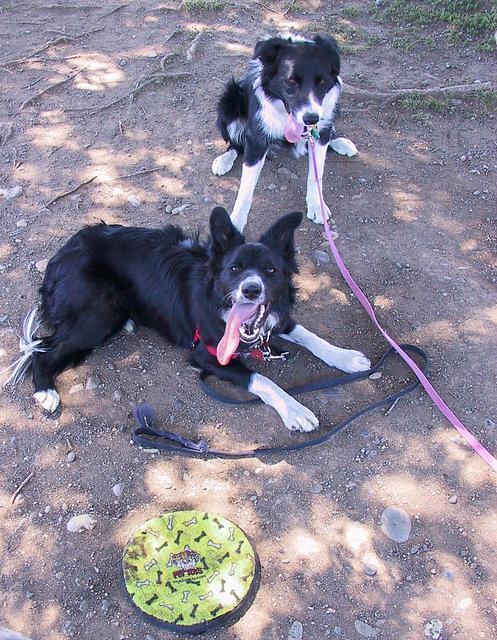What color is the lead to the dog standing to the rear side of the black dog?
Choose the correct response and explain in the format: 'Answer: answer
Rationale: rationale.'
Options: Green, purple, pink, white. Answer: pink.
Rationale: Unless you are colorblind you can tell what color the leash is. 